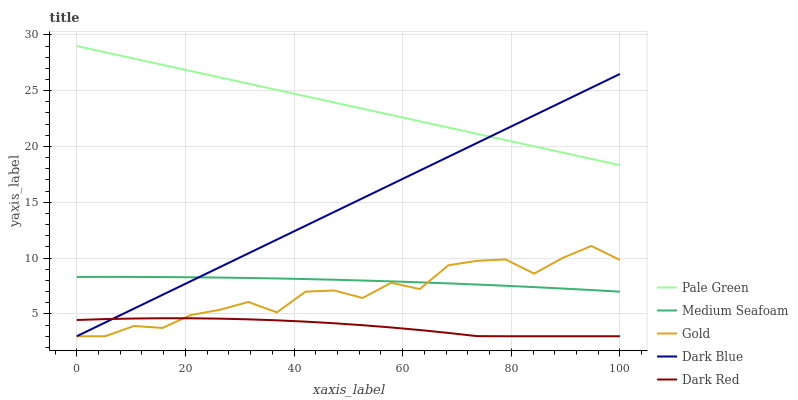Does Medium Seafoam have the minimum area under the curve?
Answer yes or no. No. Does Medium Seafoam have the maximum area under the curve?
Answer yes or no. No. Is Pale Green the smoothest?
Answer yes or no. No. Is Pale Green the roughest?
Answer yes or no. No. Does Medium Seafoam have the lowest value?
Answer yes or no. No. Does Medium Seafoam have the highest value?
Answer yes or no. No. Is Gold less than Pale Green?
Answer yes or no. Yes. Is Medium Seafoam greater than Dark Red?
Answer yes or no. Yes. Does Gold intersect Pale Green?
Answer yes or no. No. 